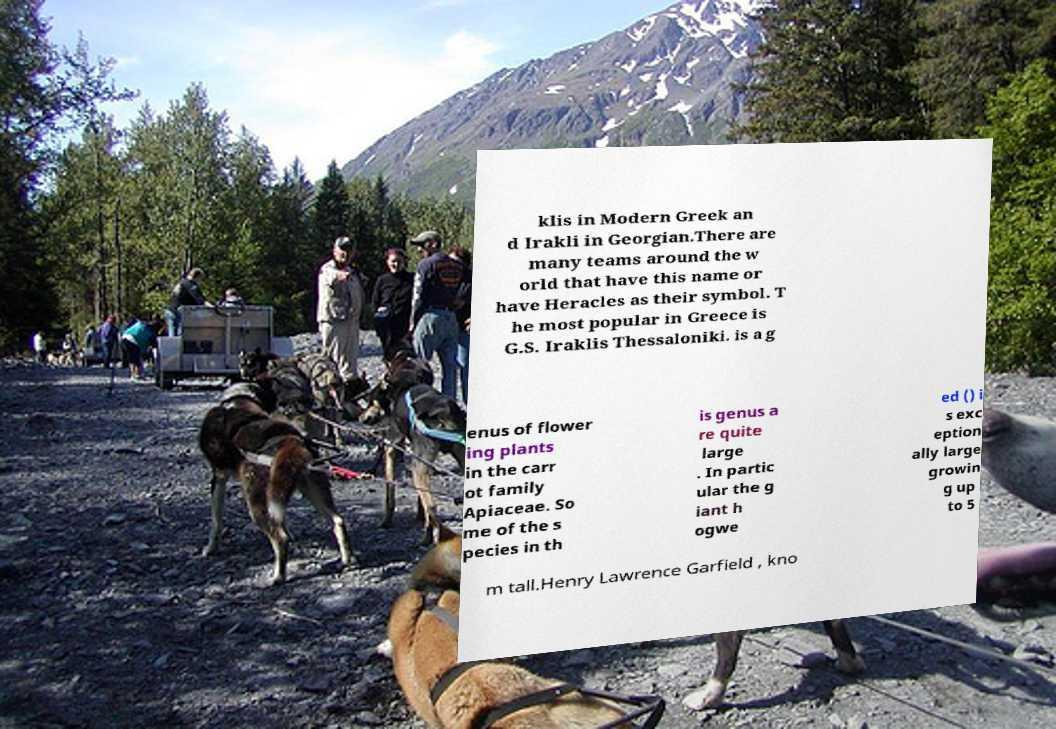Please read and relay the text visible in this image. What does it say? klis in Modern Greek an d Irakli in Georgian.There are many teams around the w orld that have this name or have Heracles as their symbol. T he most popular in Greece is G.S. Iraklis Thessaloniki. is a g enus of flower ing plants in the carr ot family Apiaceae. So me of the s pecies in th is genus a re quite large . In partic ular the g iant h ogwe ed () i s exc eption ally large growin g up to 5 m tall.Henry Lawrence Garfield , kno 